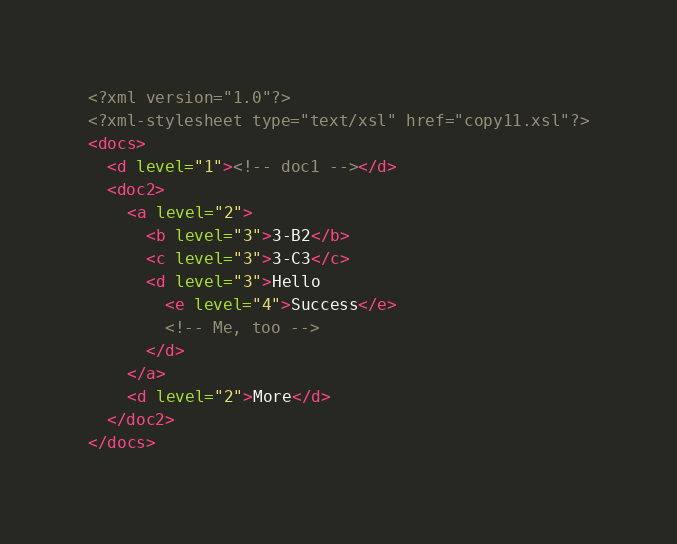<code> <loc_0><loc_0><loc_500><loc_500><_XML_><?xml version="1.0"?>
<?xml-stylesheet type="text/xsl" href="copy11.xsl"?>
<docs>
  <d level="1"><!-- doc1 --></d>
  <doc2>
    <a level="2">
      <b level="3">3-B2</b>
      <c level="3">3-C3</c>
      <d level="3">Hello
        <e level="4">Success</e>
        <!-- Me, too -->
      </d>
    </a>
    <d level="2">More</d>
  </doc2>
</docs>
</code> 